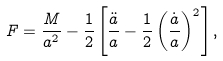<formula> <loc_0><loc_0><loc_500><loc_500>F = \frac { M } { a ^ { 2 } } - \frac { 1 } { 2 } \left [ \frac { \ddot { a } } { a } - \frac { 1 } { 2 } \left ( \frac { \dot { a } } { a } \right ) ^ { 2 } \right ] ,</formula> 